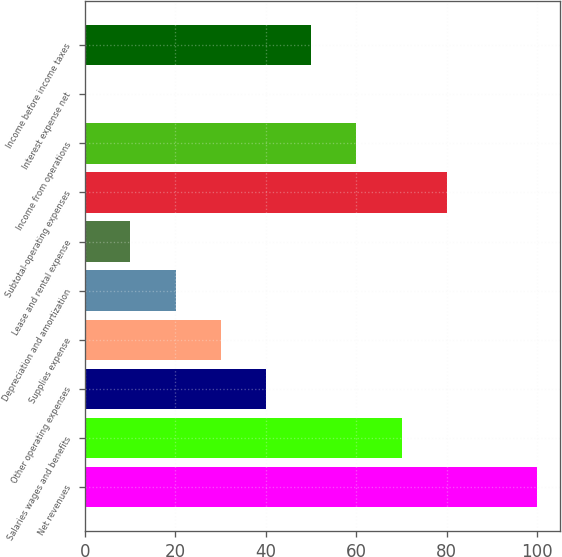<chart> <loc_0><loc_0><loc_500><loc_500><bar_chart><fcel>Net revenues<fcel>Salaries wages and benefits<fcel>Other operating expenses<fcel>Supplies expense<fcel>Depreciation and amortization<fcel>Lease and rental expense<fcel>Subtotal-operating expenses<fcel>Income from operations<fcel>Interest expense net<fcel>Income before income taxes<nl><fcel>100<fcel>70.03<fcel>40.06<fcel>30.07<fcel>20.08<fcel>10.09<fcel>80.02<fcel>60.04<fcel>0.1<fcel>50.05<nl></chart> 